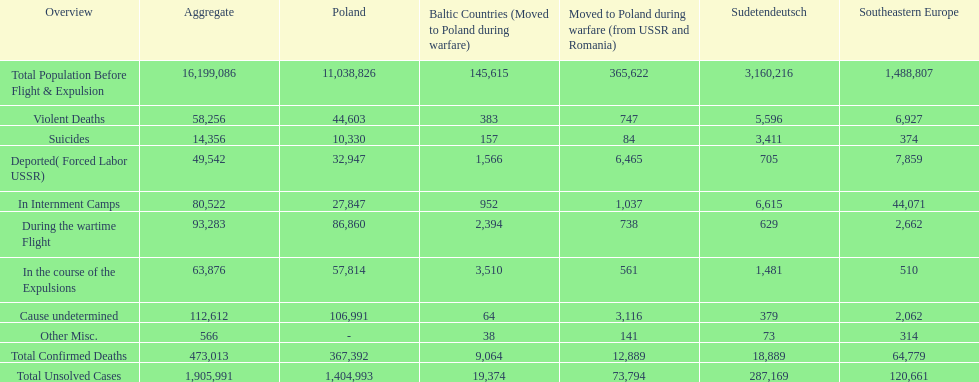What is the total number of violent deaths across all regions? 58,256. 